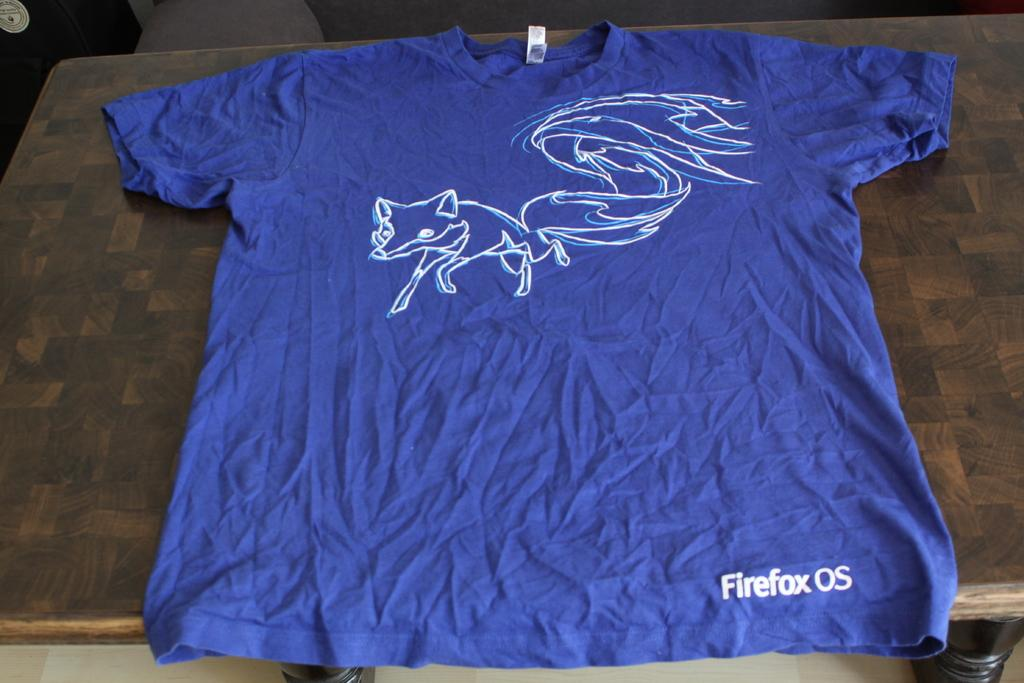Provide a one-sentence caption for the provided image. A blue t-shirt with a white outline of a fox has Firefox on the lower left side. 